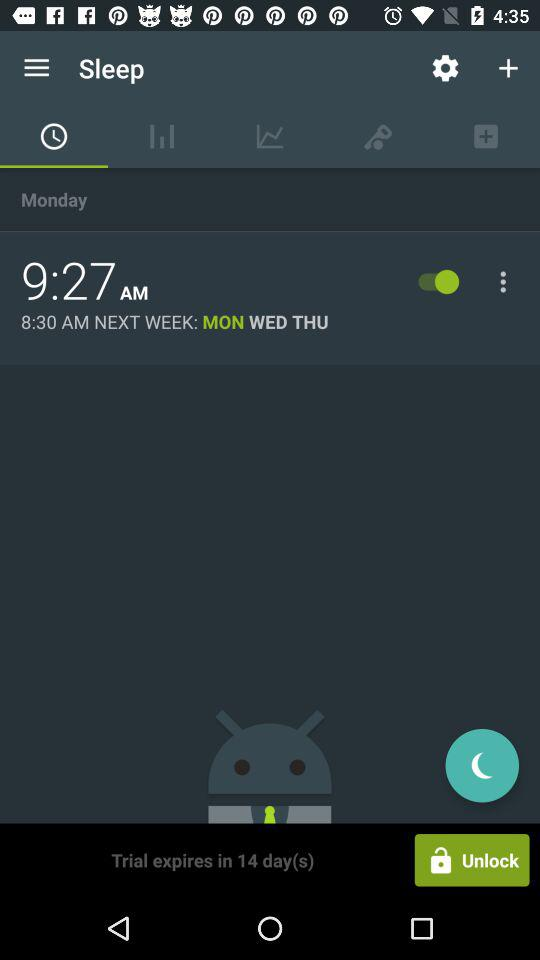What is the set time for the alarm? The set time is 9:27 AM. 